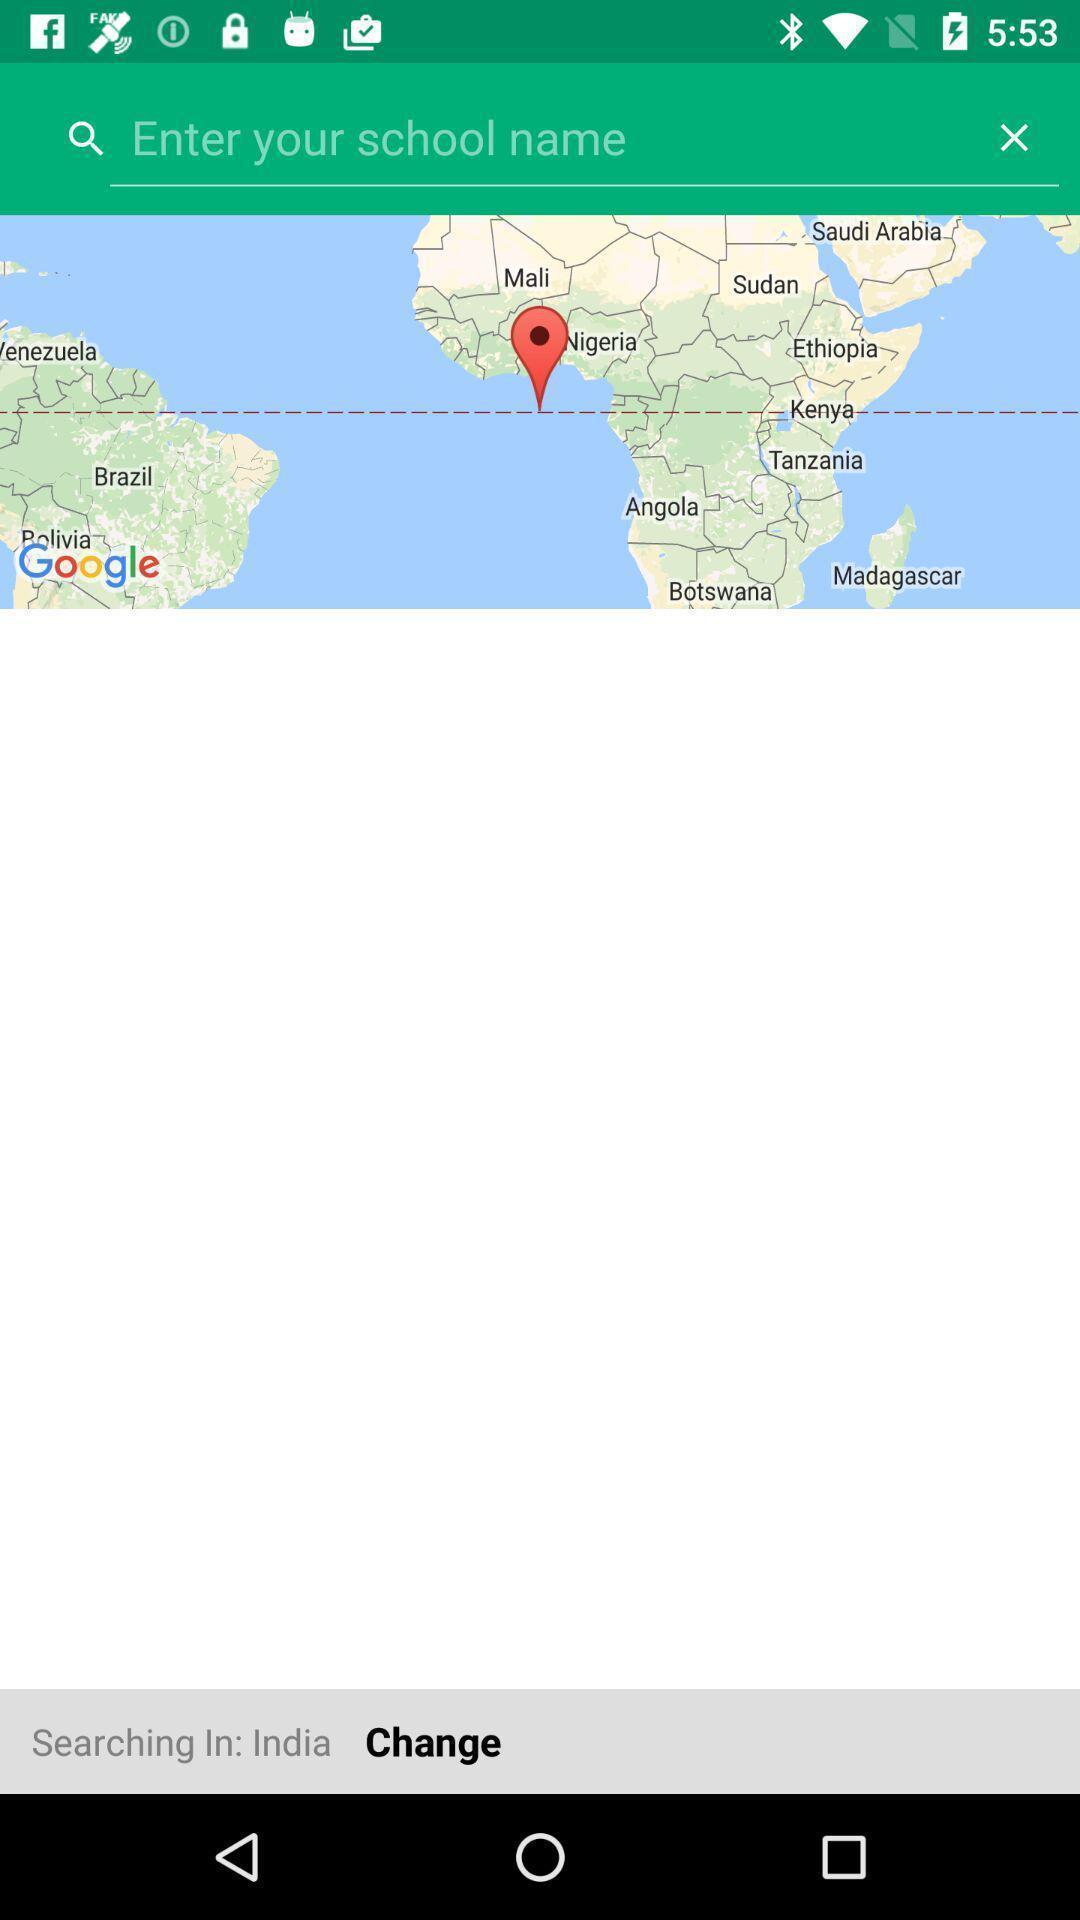Provide a textual representation of this image. Search page of an navigation application. 